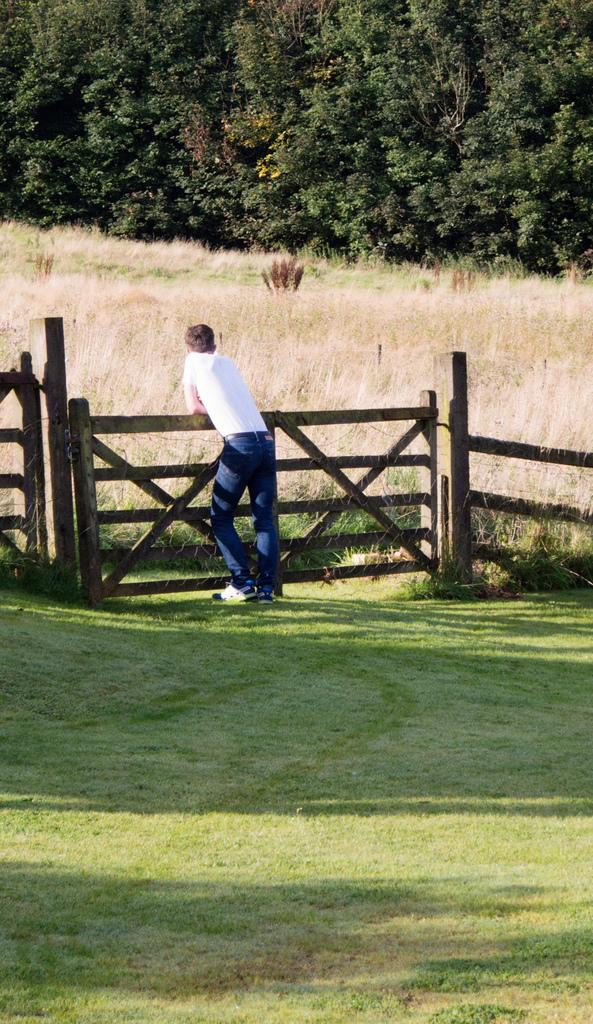What is the main subject of the image? There is a person standing in the image. Where is the person standing? The person is standing on the grass. What is near the person in the image? The person is near a fence. What can be seen in the background of the image? There is grass and trees visible in the background of the image. What type of rice is being cooked in the cannon in the image? There is no cannon or rice present in the image. Is the person standing in the image feeling hot? The image does not provide information about the person's temperature or feelings, so it cannot be determined from the image. 